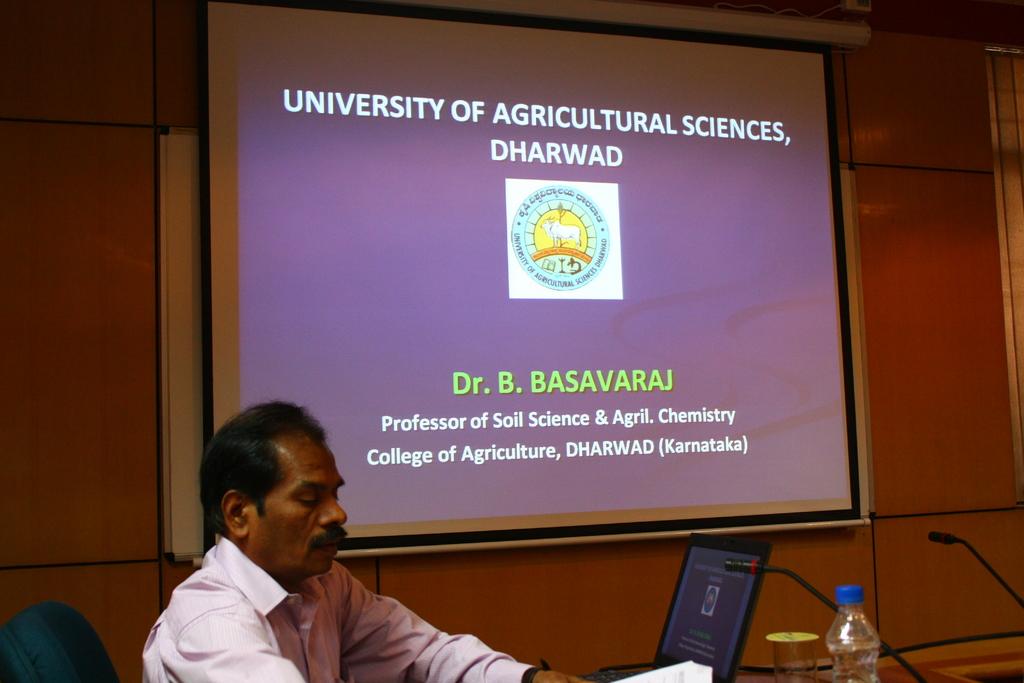What university is this from?
Your response must be concise. University of agricultural sciences. 